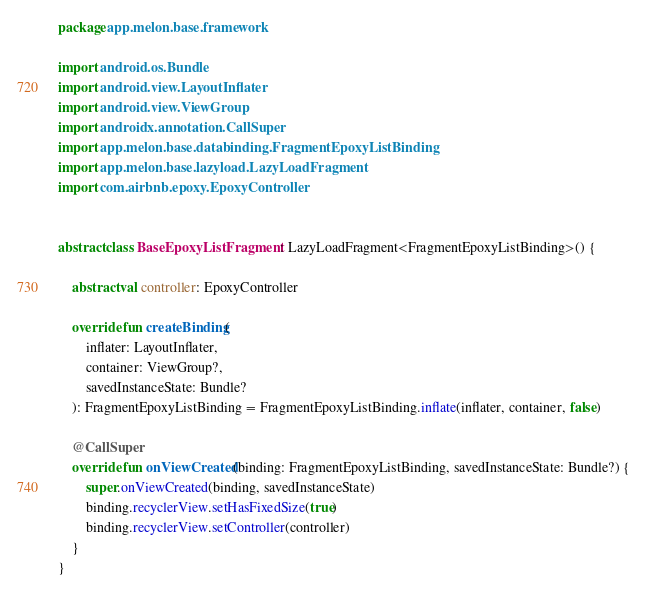<code> <loc_0><loc_0><loc_500><loc_500><_Kotlin_>package app.melon.base.framework

import android.os.Bundle
import android.view.LayoutInflater
import android.view.ViewGroup
import androidx.annotation.CallSuper
import app.melon.base.databinding.FragmentEpoxyListBinding
import app.melon.base.lazyload.LazyLoadFragment
import com.airbnb.epoxy.EpoxyController


abstract class BaseEpoxyListFragment : LazyLoadFragment<FragmentEpoxyListBinding>() {

    abstract val controller: EpoxyController

    override fun createBinding(
        inflater: LayoutInflater,
        container: ViewGroup?,
        savedInstanceState: Bundle?
    ): FragmentEpoxyListBinding = FragmentEpoxyListBinding.inflate(inflater, container, false)

    @CallSuper
    override fun onViewCreated(binding: FragmentEpoxyListBinding, savedInstanceState: Bundle?) {
        super.onViewCreated(binding, savedInstanceState)
        binding.recyclerView.setHasFixedSize(true)
        binding.recyclerView.setController(controller)
    }
}</code> 